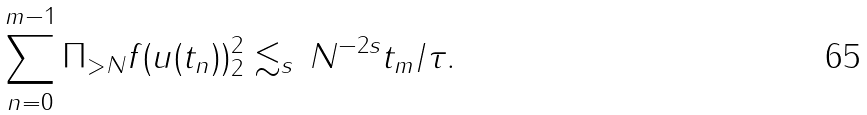<formula> <loc_0><loc_0><loc_500><loc_500>\sum _ { n = 0 } ^ { m - 1 } \| \Pi _ { > N } f ( u ( t _ { n } ) ) \| _ { 2 } ^ { 2 } \lesssim _ { s } \, N ^ { - 2 s } t _ { m } / \tau .</formula> 